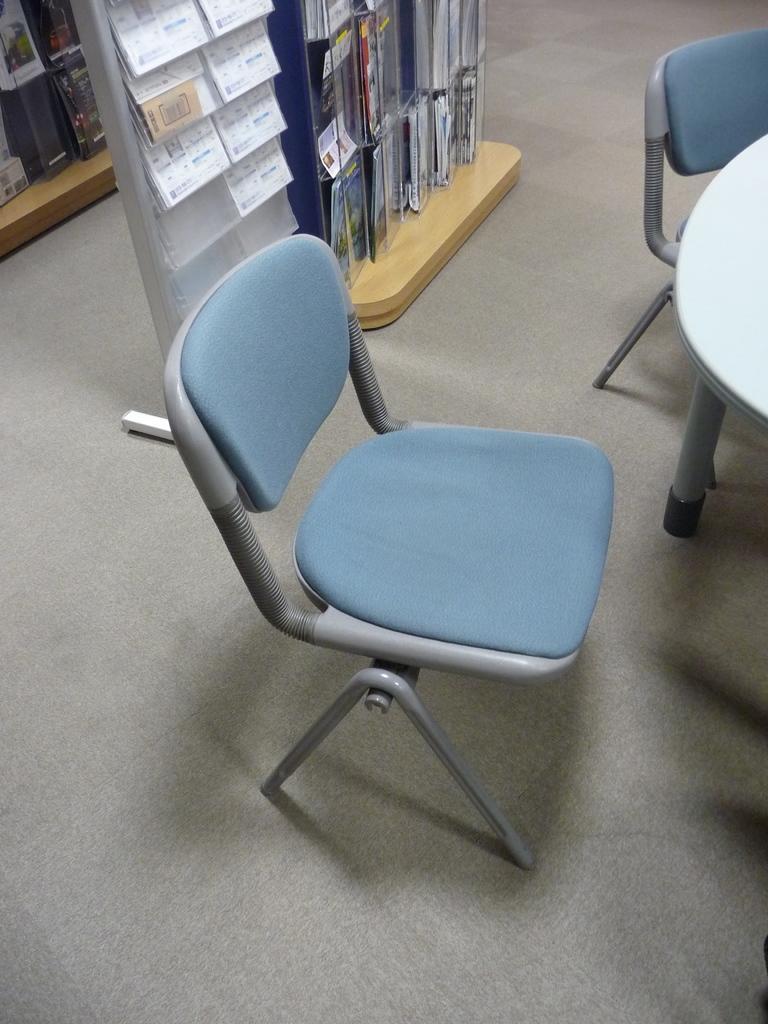Please provide a concise description of this image. In the picture we can see two chairs, table, there are some books which are arranged in the shelves, there are some other objects attached to the wooden surface. 